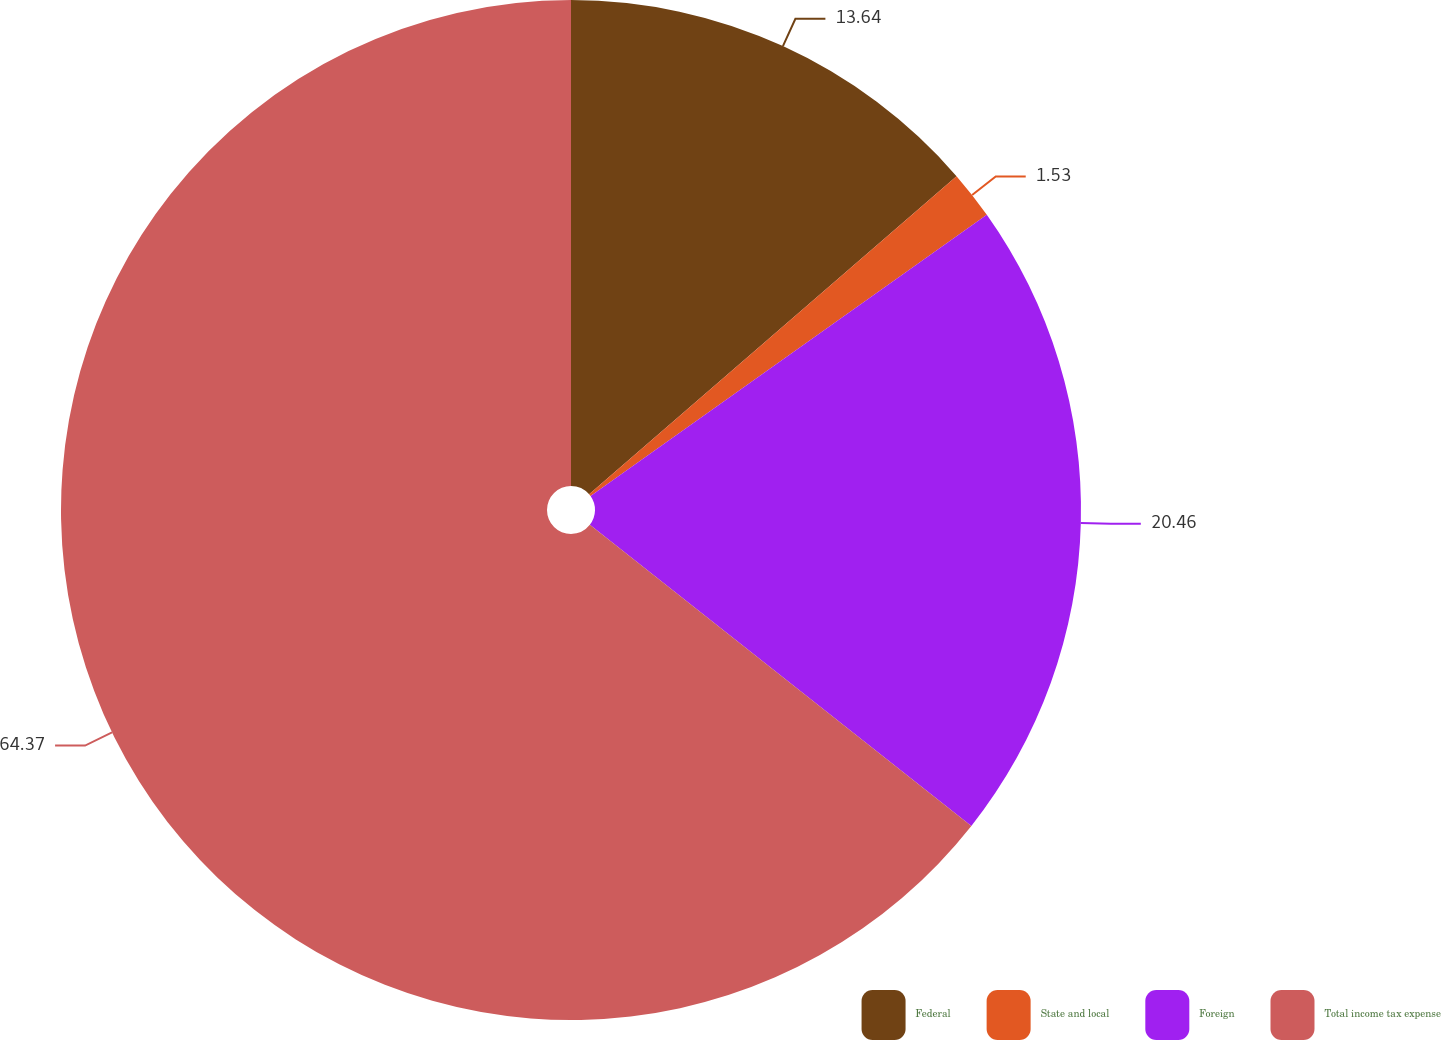<chart> <loc_0><loc_0><loc_500><loc_500><pie_chart><fcel>Federal<fcel>State and local<fcel>Foreign<fcel>Total income tax expense<nl><fcel>13.64%<fcel>1.53%<fcel>20.46%<fcel>64.36%<nl></chart> 